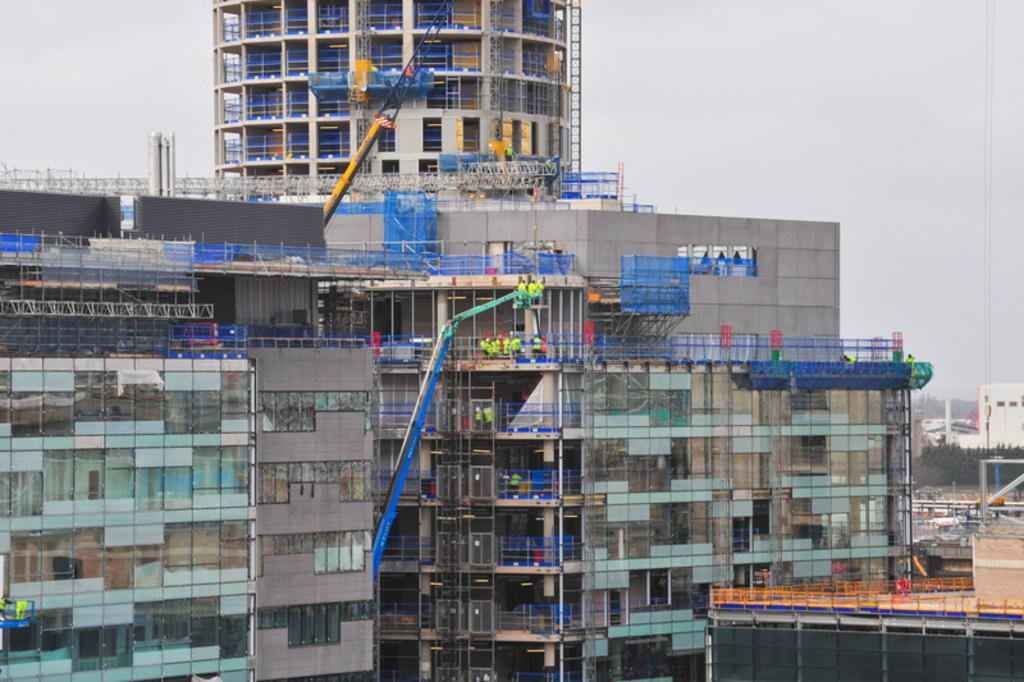What type of structures can be seen in the image? There are buildings in the image. What equipment is present in the image? There are cranes in the image. What type of barriers are visible in the image? There are fences in the image. What type of vegetation can be seen in the image? There are trees in the image. What other objects can be seen in the image? There are some objects in the image. Are there any people present in the image? Yes, there are people in the image. What can be seen in the background of the image? The sky is visible in the background of the image. What type of knee is visible in the image? There is no knee present in the image. What is the limit of the objects in the image? The provided facts do not mention any limits on the objects in the image. 